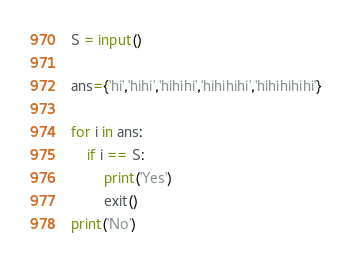Convert code to text. <code><loc_0><loc_0><loc_500><loc_500><_Python_>S = input()

ans={'hi','hihi','hihihi','hihihihi','hihihihihi'}

for i in ans:
    if i == S:
        print('Yes')
        exit()
print('No')</code> 